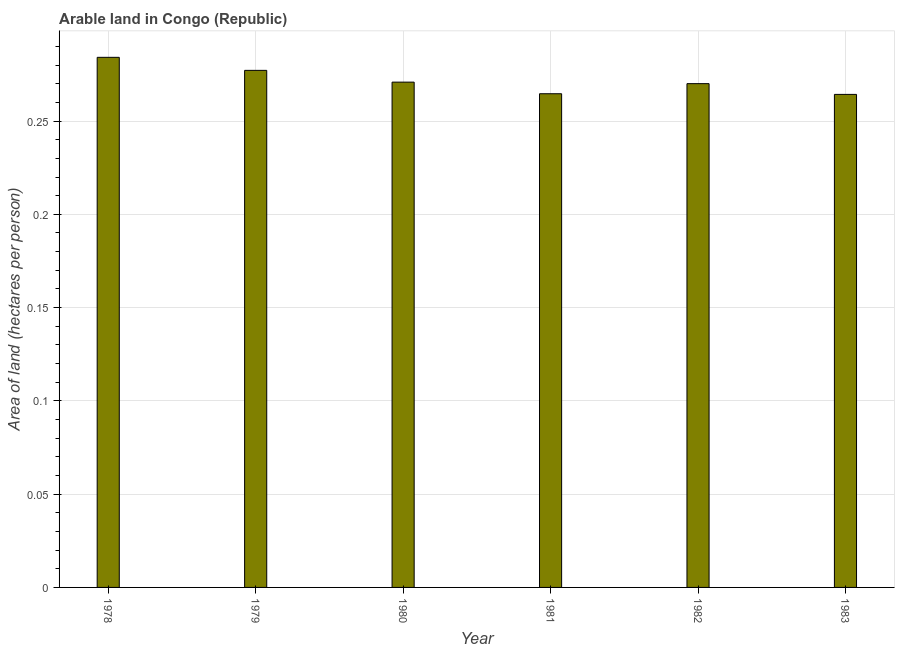What is the title of the graph?
Your answer should be compact. Arable land in Congo (Republic). What is the label or title of the Y-axis?
Your answer should be very brief. Area of land (hectares per person). What is the area of arable land in 1981?
Keep it short and to the point. 0.26. Across all years, what is the maximum area of arable land?
Provide a short and direct response. 0.28. Across all years, what is the minimum area of arable land?
Ensure brevity in your answer.  0.26. In which year was the area of arable land maximum?
Offer a very short reply. 1978. In which year was the area of arable land minimum?
Offer a terse response. 1983. What is the sum of the area of arable land?
Your response must be concise. 1.63. What is the difference between the area of arable land in 1978 and 1983?
Offer a very short reply. 0.02. What is the average area of arable land per year?
Your response must be concise. 0.27. What is the median area of arable land?
Offer a very short reply. 0.27. Do a majority of the years between 1979 and 1978 (inclusive) have area of arable land greater than 0.25 hectares per person?
Make the answer very short. No. What is the ratio of the area of arable land in 1979 to that in 1981?
Provide a succinct answer. 1.05. Is the area of arable land in 1979 less than that in 1981?
Offer a terse response. No. Is the difference between the area of arable land in 1978 and 1979 greater than the difference between any two years?
Give a very brief answer. No. What is the difference between the highest and the second highest area of arable land?
Provide a short and direct response. 0.01. How many bars are there?
Offer a terse response. 6. Are all the bars in the graph horizontal?
Your response must be concise. No. Are the values on the major ticks of Y-axis written in scientific E-notation?
Your answer should be compact. No. What is the Area of land (hectares per person) in 1978?
Your response must be concise. 0.28. What is the Area of land (hectares per person) in 1979?
Keep it short and to the point. 0.28. What is the Area of land (hectares per person) in 1980?
Provide a succinct answer. 0.27. What is the Area of land (hectares per person) of 1981?
Make the answer very short. 0.26. What is the Area of land (hectares per person) of 1982?
Offer a terse response. 0.27. What is the Area of land (hectares per person) in 1983?
Your answer should be very brief. 0.26. What is the difference between the Area of land (hectares per person) in 1978 and 1979?
Give a very brief answer. 0.01. What is the difference between the Area of land (hectares per person) in 1978 and 1980?
Offer a very short reply. 0.01. What is the difference between the Area of land (hectares per person) in 1978 and 1981?
Keep it short and to the point. 0.02. What is the difference between the Area of land (hectares per person) in 1978 and 1982?
Give a very brief answer. 0.01. What is the difference between the Area of land (hectares per person) in 1978 and 1983?
Offer a very short reply. 0.02. What is the difference between the Area of land (hectares per person) in 1979 and 1980?
Provide a succinct answer. 0.01. What is the difference between the Area of land (hectares per person) in 1979 and 1981?
Offer a very short reply. 0.01. What is the difference between the Area of land (hectares per person) in 1979 and 1982?
Your answer should be compact. 0.01. What is the difference between the Area of land (hectares per person) in 1979 and 1983?
Your answer should be compact. 0.01. What is the difference between the Area of land (hectares per person) in 1980 and 1981?
Give a very brief answer. 0.01. What is the difference between the Area of land (hectares per person) in 1980 and 1982?
Provide a succinct answer. 0. What is the difference between the Area of land (hectares per person) in 1980 and 1983?
Your answer should be compact. 0.01. What is the difference between the Area of land (hectares per person) in 1981 and 1982?
Your answer should be very brief. -0.01. What is the difference between the Area of land (hectares per person) in 1981 and 1983?
Your answer should be very brief. 0. What is the difference between the Area of land (hectares per person) in 1982 and 1983?
Provide a short and direct response. 0.01. What is the ratio of the Area of land (hectares per person) in 1978 to that in 1980?
Your response must be concise. 1.05. What is the ratio of the Area of land (hectares per person) in 1978 to that in 1981?
Give a very brief answer. 1.07. What is the ratio of the Area of land (hectares per person) in 1978 to that in 1982?
Your response must be concise. 1.05. What is the ratio of the Area of land (hectares per person) in 1978 to that in 1983?
Give a very brief answer. 1.07. What is the ratio of the Area of land (hectares per person) in 1979 to that in 1980?
Provide a succinct answer. 1.02. What is the ratio of the Area of land (hectares per person) in 1979 to that in 1981?
Provide a short and direct response. 1.05. What is the ratio of the Area of land (hectares per person) in 1979 to that in 1983?
Ensure brevity in your answer.  1.05. What is the ratio of the Area of land (hectares per person) in 1980 to that in 1982?
Give a very brief answer. 1. What is the ratio of the Area of land (hectares per person) in 1980 to that in 1983?
Offer a terse response. 1.02. What is the ratio of the Area of land (hectares per person) in 1981 to that in 1982?
Keep it short and to the point. 0.98. What is the ratio of the Area of land (hectares per person) in 1981 to that in 1983?
Ensure brevity in your answer.  1. What is the ratio of the Area of land (hectares per person) in 1982 to that in 1983?
Your response must be concise. 1.02. 